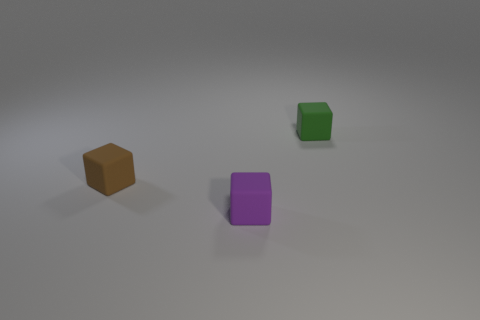Subtract all green blocks. How many blocks are left? 2 Add 1 brown matte blocks. How many objects exist? 4 Subtract all purple cylinders. How many red blocks are left? 0 Subtract all green cubes. Subtract all tiny brown rubber cubes. How many objects are left? 1 Add 2 small brown blocks. How many small brown blocks are left? 3 Add 1 small brown objects. How many small brown objects exist? 2 Subtract 0 yellow spheres. How many objects are left? 3 Subtract all blue cubes. Subtract all cyan balls. How many cubes are left? 3 